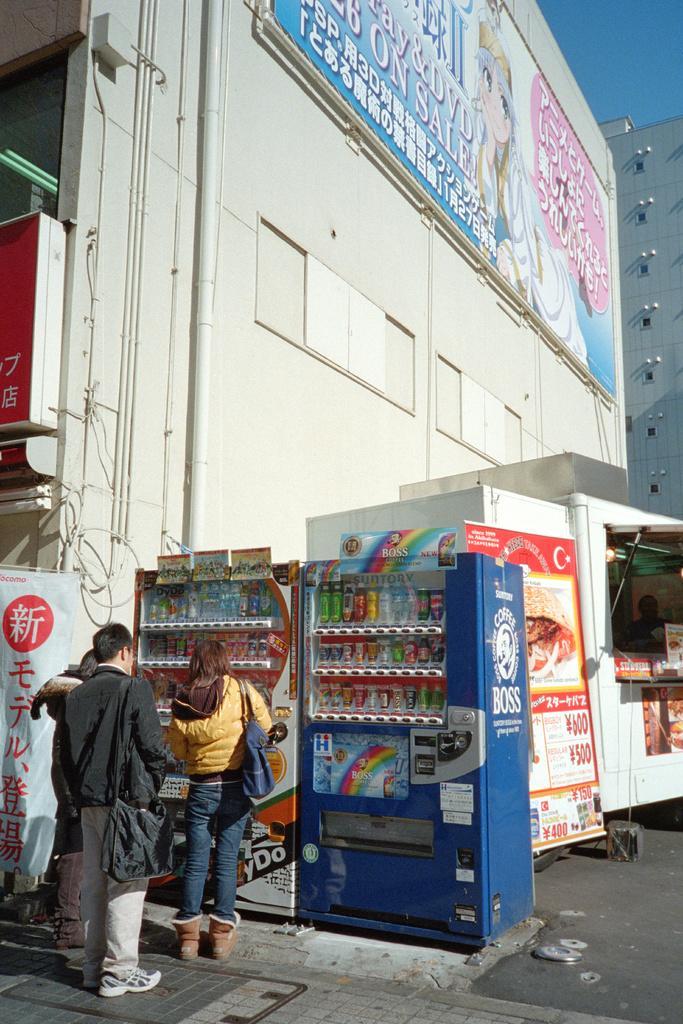Please provide a concise description of this image. In this image we can see people, vending machines, banners, road, and a stall. In the background we can see boards, buildings, and sky. 